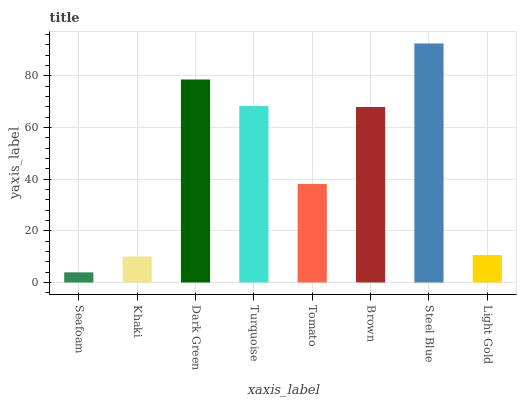Is Seafoam the minimum?
Answer yes or no. Yes. Is Steel Blue the maximum?
Answer yes or no. Yes. Is Khaki the minimum?
Answer yes or no. No. Is Khaki the maximum?
Answer yes or no. No. Is Khaki greater than Seafoam?
Answer yes or no. Yes. Is Seafoam less than Khaki?
Answer yes or no. Yes. Is Seafoam greater than Khaki?
Answer yes or no. No. Is Khaki less than Seafoam?
Answer yes or no. No. Is Brown the high median?
Answer yes or no. Yes. Is Tomato the low median?
Answer yes or no. Yes. Is Seafoam the high median?
Answer yes or no. No. Is Khaki the low median?
Answer yes or no. No. 